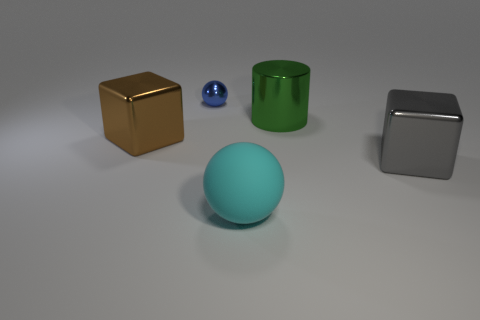Add 1 gray objects. How many objects exist? 6 Subtract all balls. How many objects are left? 3 Subtract all green cylinders. Subtract all blocks. How many objects are left? 2 Add 5 large green metallic cylinders. How many large green metallic cylinders are left? 6 Add 3 small green matte blocks. How many small green matte blocks exist? 3 Subtract 0 cyan cylinders. How many objects are left? 5 